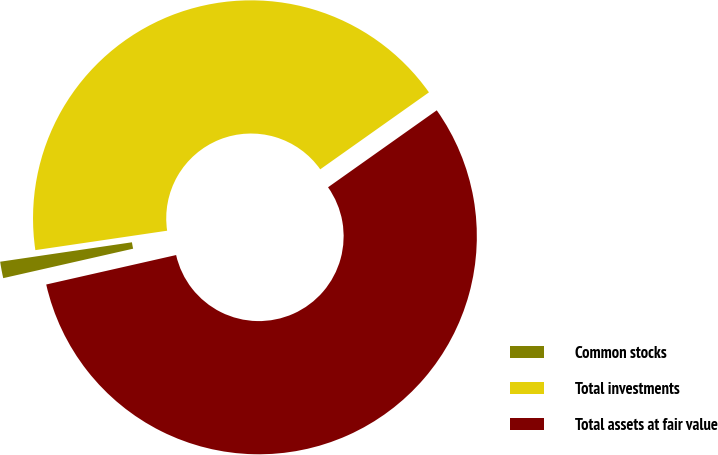Convert chart. <chart><loc_0><loc_0><loc_500><loc_500><pie_chart><fcel>Common stocks<fcel>Total investments<fcel>Total assets at fair value<nl><fcel>1.22%<fcel>42.52%<fcel>56.25%<nl></chart> 